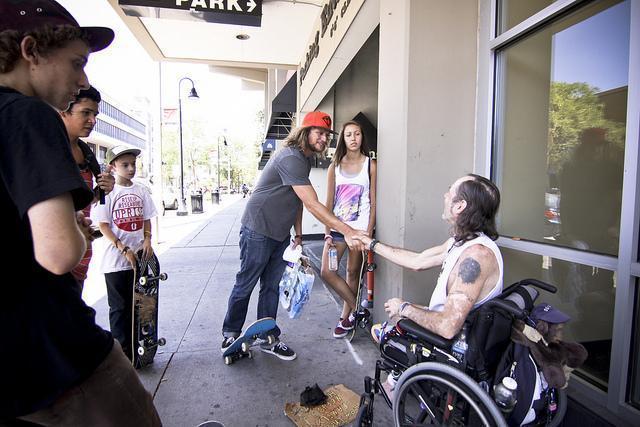How many people are wearing hats in the photo?
Give a very brief answer. 3. How many bikes in the shot?
Give a very brief answer. 0. How many people can you see?
Give a very brief answer. 6. How many backpacks are in the photo?
Give a very brief answer. 1. 